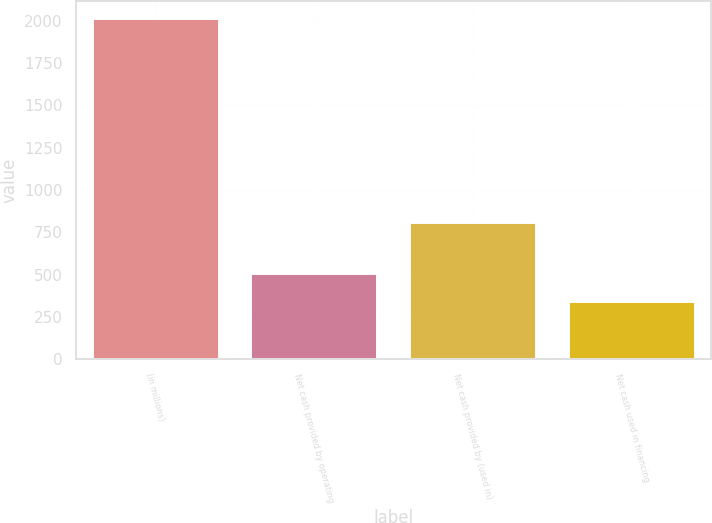Convert chart to OTSL. <chart><loc_0><loc_0><loc_500><loc_500><bar_chart><fcel>(in millions)<fcel>Net cash provided by operating<fcel>Net cash provided by (used in)<fcel>Net cash used in financing<nl><fcel>2016<fcel>510.48<fcel>809.5<fcel>343.2<nl></chart> 